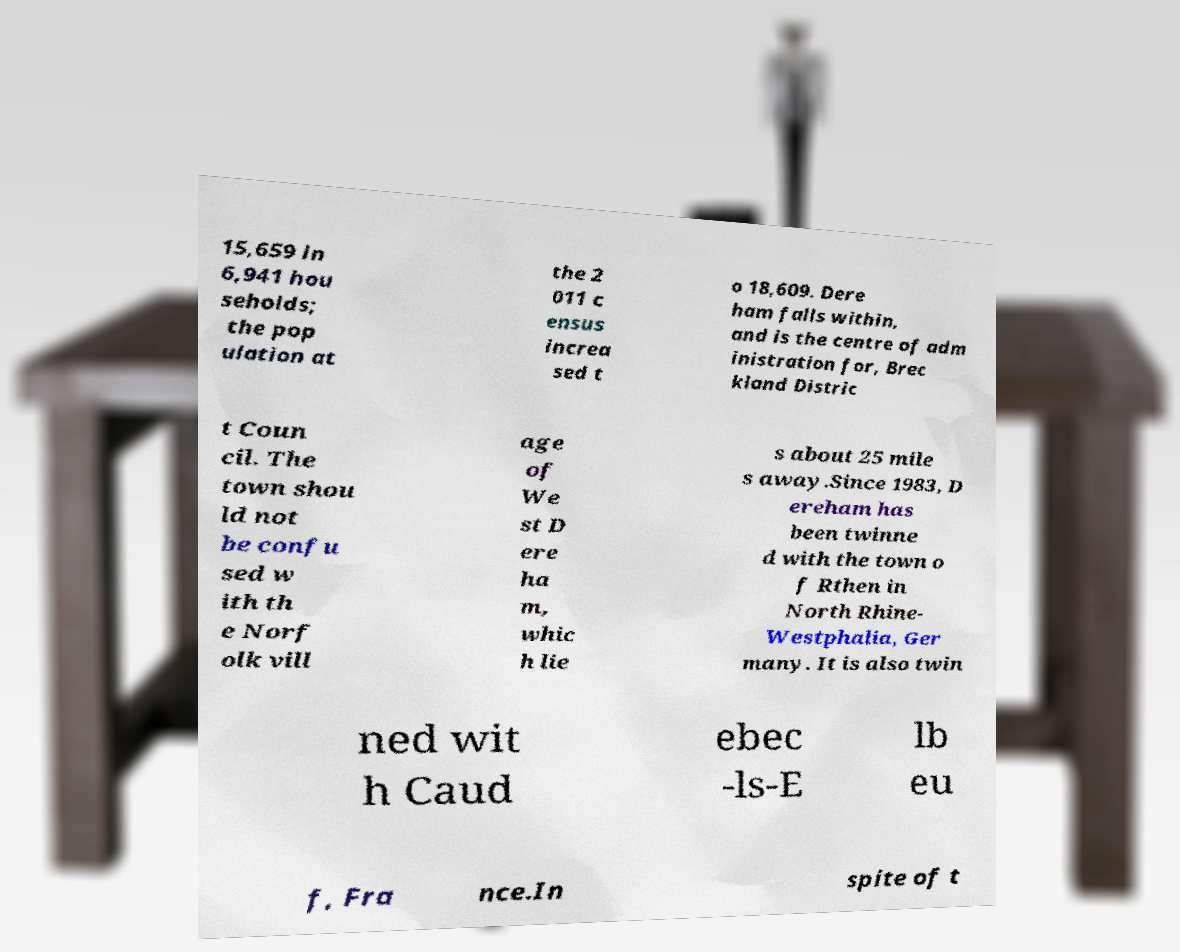Could you assist in decoding the text presented in this image and type it out clearly? 15,659 in 6,941 hou seholds; the pop ulation at the 2 011 c ensus increa sed t o 18,609. Dere ham falls within, and is the centre of adm inistration for, Brec kland Distric t Coun cil. The town shou ld not be confu sed w ith th e Norf olk vill age of We st D ere ha m, whic h lie s about 25 mile s away.Since 1983, D ereham has been twinne d with the town o f Rthen in North Rhine- Westphalia, Ger many. It is also twin ned wit h Caud ebec -ls-E lb eu f, Fra nce.In spite of t 